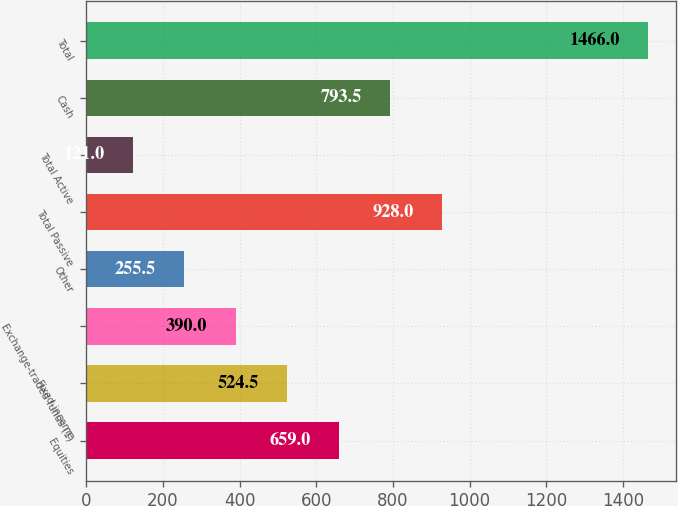Convert chart to OTSL. <chart><loc_0><loc_0><loc_500><loc_500><bar_chart><fcel>Equities<fcel>Fixed-income<fcel>Exchange-traded funds (1)<fcel>Other<fcel>Total Passive<fcel>Total Active<fcel>Cash<fcel>Total<nl><fcel>659<fcel>524.5<fcel>390<fcel>255.5<fcel>928<fcel>121<fcel>793.5<fcel>1466<nl></chart> 